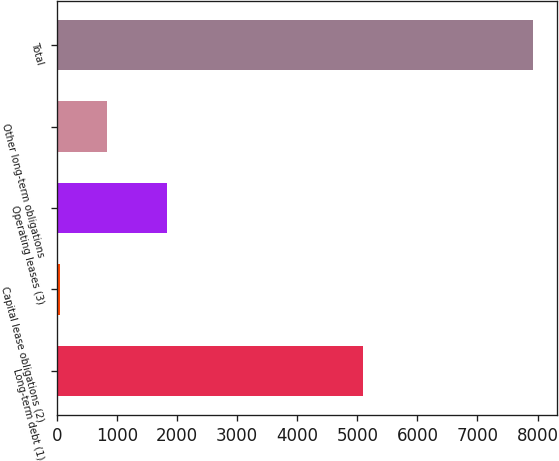<chart> <loc_0><loc_0><loc_500><loc_500><bar_chart><fcel>Long-term debt (1)<fcel>Capital lease obligations (2)<fcel>Operating leases (3)<fcel>Other long-term obligations<fcel>Total<nl><fcel>5093.4<fcel>53.7<fcel>1828.5<fcel>840.24<fcel>7919.1<nl></chart> 